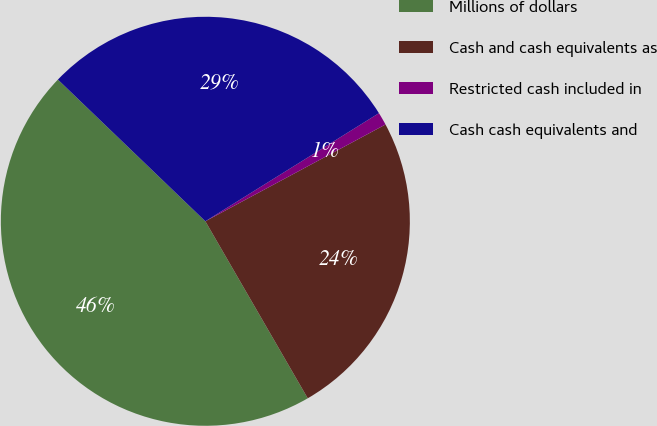Convert chart. <chart><loc_0><loc_0><loc_500><loc_500><pie_chart><fcel>Millions of dollars<fcel>Cash and cash equivalents as<fcel>Restricted cash included in<fcel>Cash cash equivalents and<nl><fcel>45.53%<fcel>24.5%<fcel>1.02%<fcel>28.95%<nl></chart> 